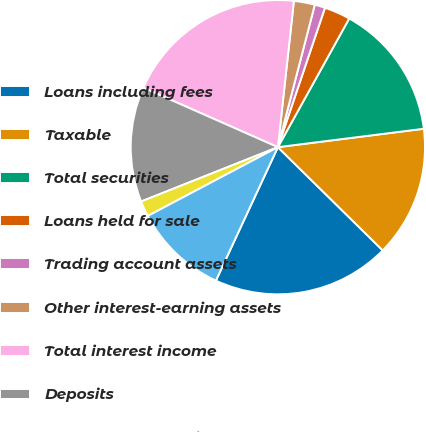Convert chart to OTSL. <chart><loc_0><loc_0><loc_500><loc_500><pie_chart><fcel>Loans including fees<fcel>Taxable<fcel>Total securities<fcel>Loans held for sale<fcel>Trading account assets<fcel>Other interest-earning assets<fcel>Total interest income<fcel>Deposits<fcel>Short-term borrowings<fcel>Long-term borrowings<nl><fcel>19.54%<fcel>14.37%<fcel>14.94%<fcel>2.87%<fcel>1.15%<fcel>2.3%<fcel>20.11%<fcel>12.64%<fcel>1.72%<fcel>10.34%<nl></chart> 